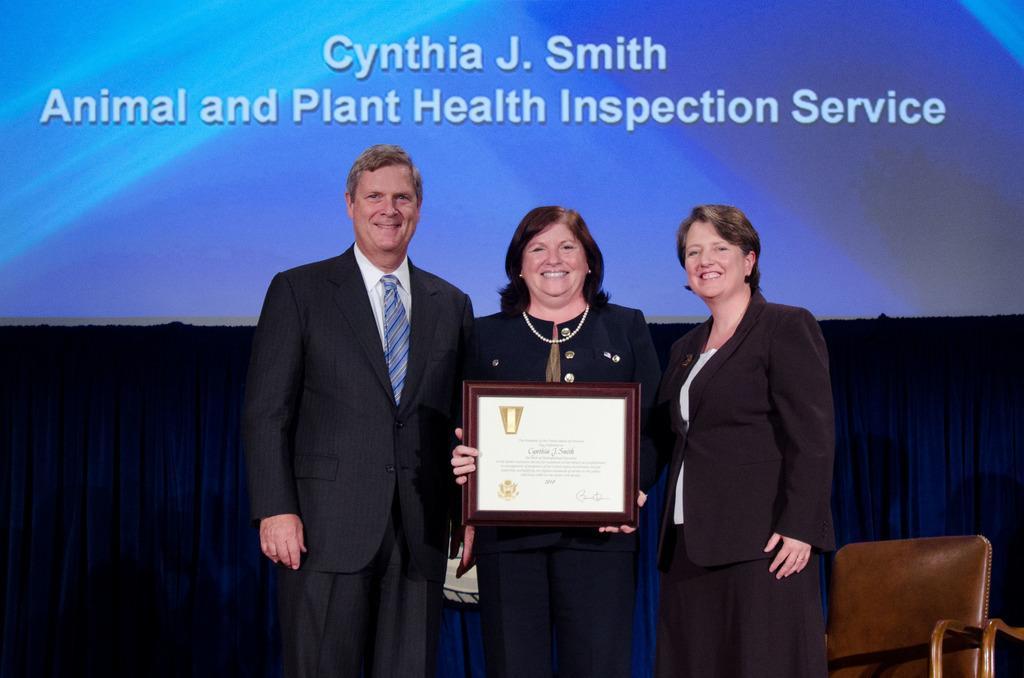How would you summarize this image in a sentence or two? There are three persons standing. Middle person is holding a momentum. In the back there is curtain and wall with something is written. On the right side there is a chair. 